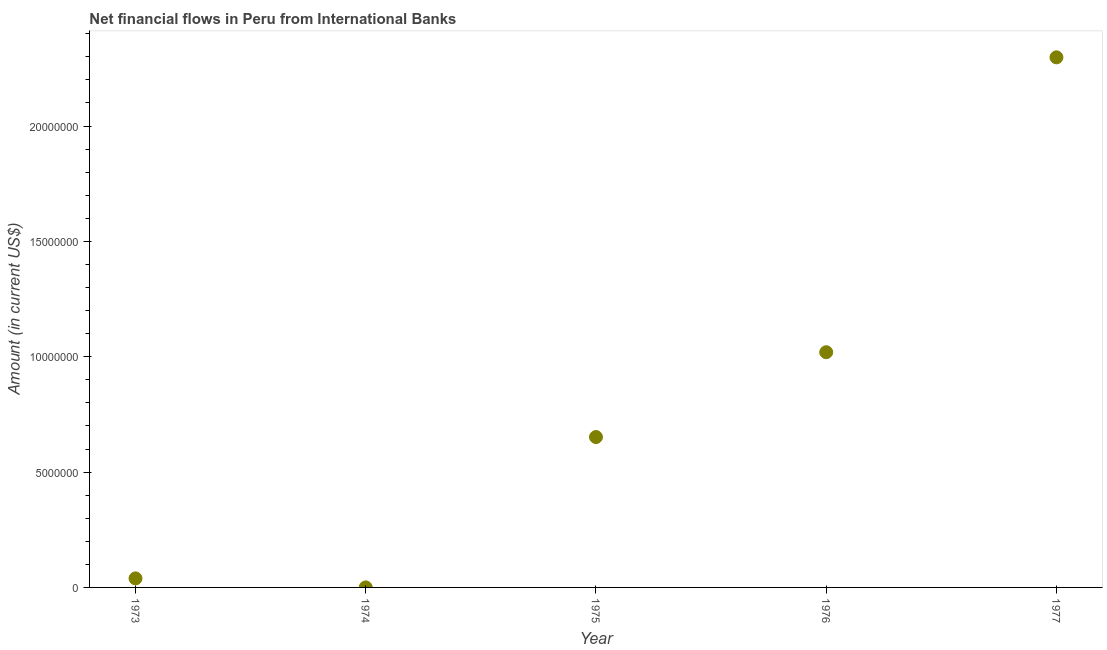What is the net financial flows from ibrd in 1977?
Your answer should be compact. 2.30e+07. Across all years, what is the maximum net financial flows from ibrd?
Your response must be concise. 2.30e+07. Across all years, what is the minimum net financial flows from ibrd?
Your response must be concise. 1000. In which year was the net financial flows from ibrd maximum?
Offer a terse response. 1977. In which year was the net financial flows from ibrd minimum?
Provide a succinct answer. 1974. What is the sum of the net financial flows from ibrd?
Keep it short and to the point. 4.01e+07. What is the difference between the net financial flows from ibrd in 1973 and 1977?
Offer a terse response. -2.26e+07. What is the average net financial flows from ibrd per year?
Give a very brief answer. 8.02e+06. What is the median net financial flows from ibrd?
Your answer should be compact. 6.52e+06. In how many years, is the net financial flows from ibrd greater than 11000000 US$?
Keep it short and to the point. 1. Do a majority of the years between 1976 and 1977 (inclusive) have net financial flows from ibrd greater than 18000000 US$?
Provide a short and direct response. No. What is the ratio of the net financial flows from ibrd in 1975 to that in 1977?
Provide a succinct answer. 0.28. Is the net financial flows from ibrd in 1974 less than that in 1976?
Give a very brief answer. Yes. What is the difference between the highest and the second highest net financial flows from ibrd?
Your response must be concise. 1.28e+07. What is the difference between the highest and the lowest net financial flows from ibrd?
Your answer should be very brief. 2.30e+07. How many years are there in the graph?
Your response must be concise. 5. What is the difference between two consecutive major ticks on the Y-axis?
Keep it short and to the point. 5.00e+06. Are the values on the major ticks of Y-axis written in scientific E-notation?
Keep it short and to the point. No. Does the graph contain any zero values?
Offer a terse response. No. What is the title of the graph?
Offer a terse response. Net financial flows in Peru from International Banks. What is the label or title of the X-axis?
Your answer should be very brief. Year. What is the Amount (in current US$) in 1973?
Make the answer very short. 3.92e+05. What is the Amount (in current US$) in 1975?
Offer a terse response. 6.52e+06. What is the Amount (in current US$) in 1976?
Offer a very short reply. 1.02e+07. What is the Amount (in current US$) in 1977?
Offer a very short reply. 2.30e+07. What is the difference between the Amount (in current US$) in 1973 and 1974?
Offer a very short reply. 3.91e+05. What is the difference between the Amount (in current US$) in 1973 and 1975?
Make the answer very short. -6.13e+06. What is the difference between the Amount (in current US$) in 1973 and 1976?
Your answer should be very brief. -9.80e+06. What is the difference between the Amount (in current US$) in 1973 and 1977?
Give a very brief answer. -2.26e+07. What is the difference between the Amount (in current US$) in 1974 and 1975?
Ensure brevity in your answer.  -6.52e+06. What is the difference between the Amount (in current US$) in 1974 and 1976?
Give a very brief answer. -1.02e+07. What is the difference between the Amount (in current US$) in 1974 and 1977?
Your response must be concise. -2.30e+07. What is the difference between the Amount (in current US$) in 1975 and 1976?
Keep it short and to the point. -3.68e+06. What is the difference between the Amount (in current US$) in 1975 and 1977?
Your answer should be very brief. -1.65e+07. What is the difference between the Amount (in current US$) in 1976 and 1977?
Keep it short and to the point. -1.28e+07. What is the ratio of the Amount (in current US$) in 1973 to that in 1974?
Offer a very short reply. 392. What is the ratio of the Amount (in current US$) in 1973 to that in 1976?
Provide a succinct answer. 0.04. What is the ratio of the Amount (in current US$) in 1973 to that in 1977?
Your answer should be very brief. 0.02. What is the ratio of the Amount (in current US$) in 1975 to that in 1976?
Ensure brevity in your answer.  0.64. What is the ratio of the Amount (in current US$) in 1975 to that in 1977?
Offer a very short reply. 0.28. What is the ratio of the Amount (in current US$) in 1976 to that in 1977?
Your answer should be very brief. 0.44. 